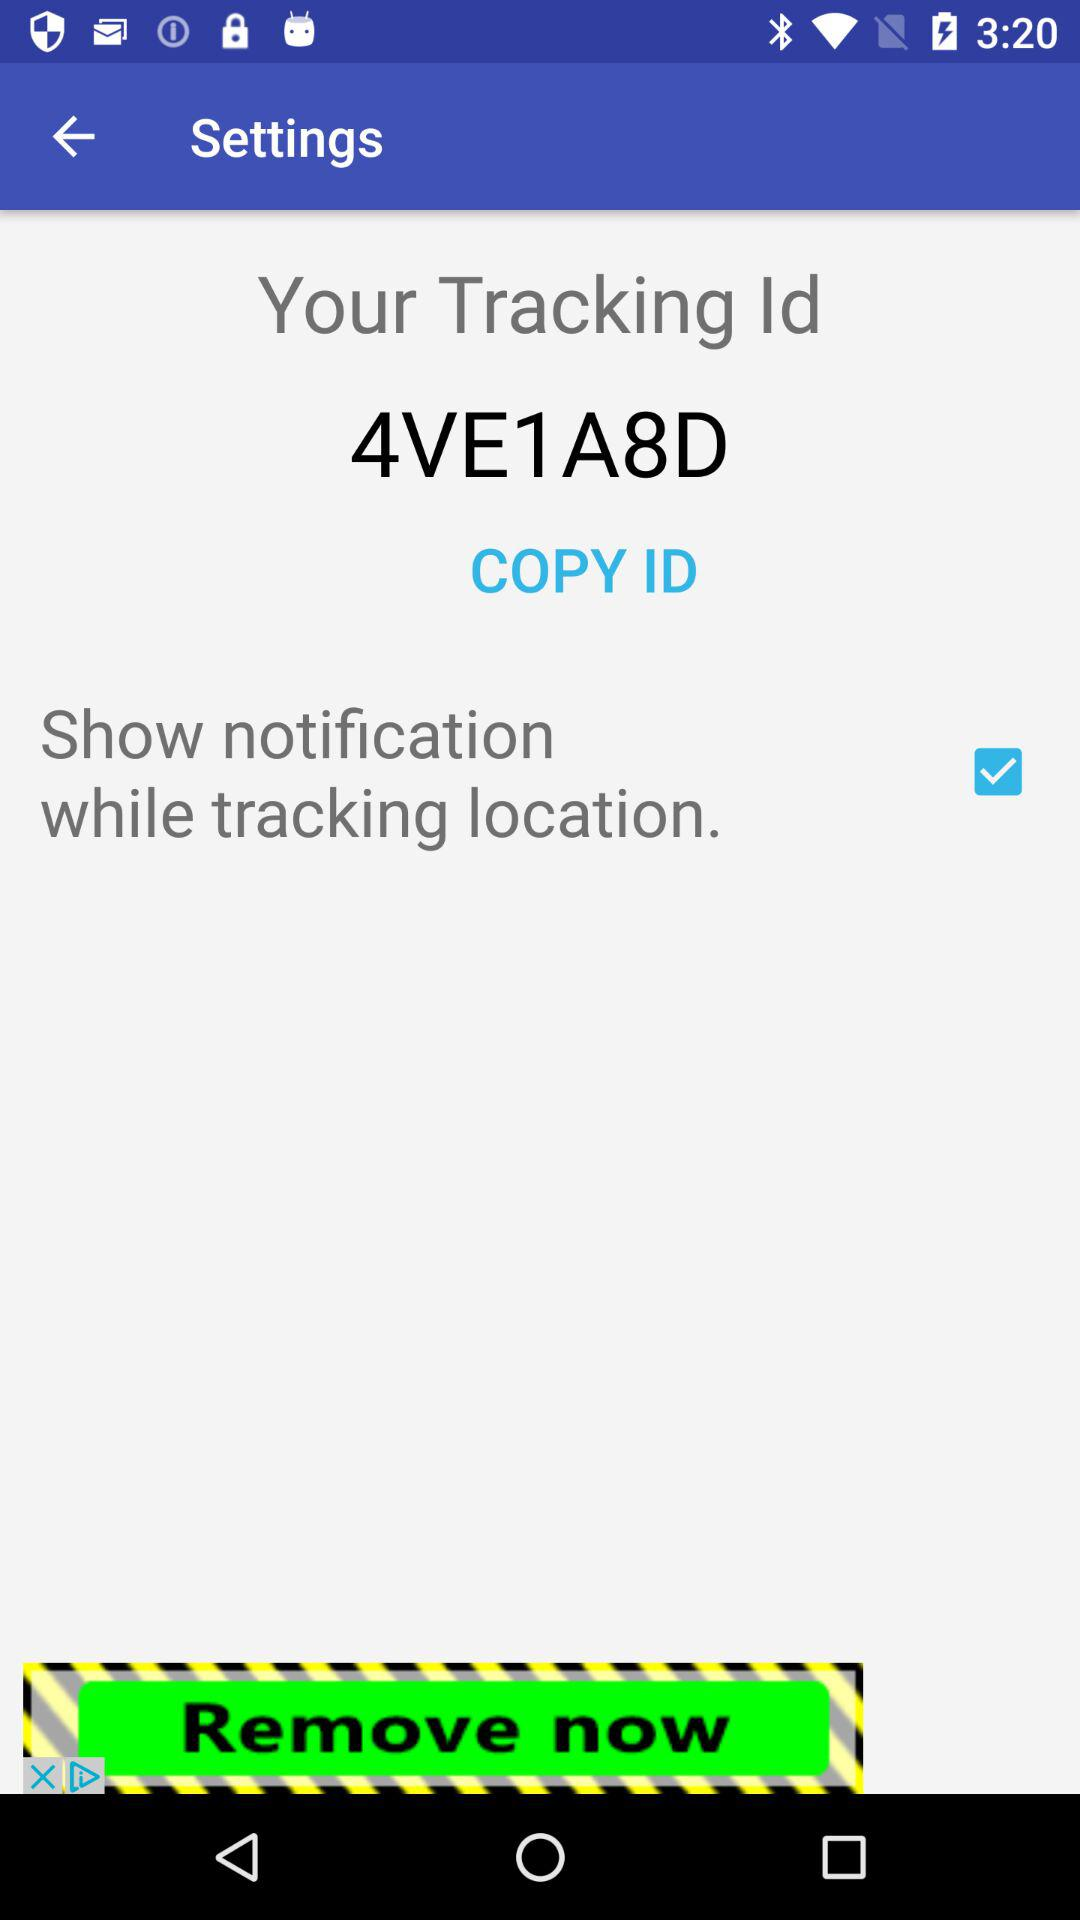What is the status of "Show notification while tracking location"? The status is "on". 